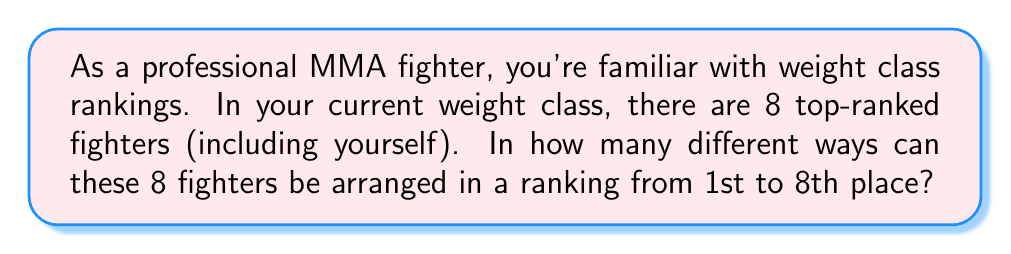Provide a solution to this math problem. Let's approach this step-by-step:

1) This is a permutation problem. We need to arrange 8 distinct fighters in 8 distinct positions.

2) For the first position (1st place), we have 8 choices, as any of the 8 fighters could be ranked first.

3) After the first position is filled, we have 7 fighters left for the second position.

4) For the third position, we'll have 6 choices, and so on.

5) This continues until we reach the last position, where we'll have only 1 fighter left to place.

6) Mathematically, this is represented as:

   $$8 \times 7 \times 6 \times 5 \times 4 \times 3 \times 2 \times 1$$

7) This is also written as 8! (8 factorial).

8) We can calculate this:
   
   $$8! = 8 \times 7 \times 6 \times 5 \times 4 \times 3 \times 2 \times 1 = 40,320$$

Therefore, there are 40,320 different ways to arrange 8 fighters in a ranking from 1st to 8th place.
Answer: $40,320$ 